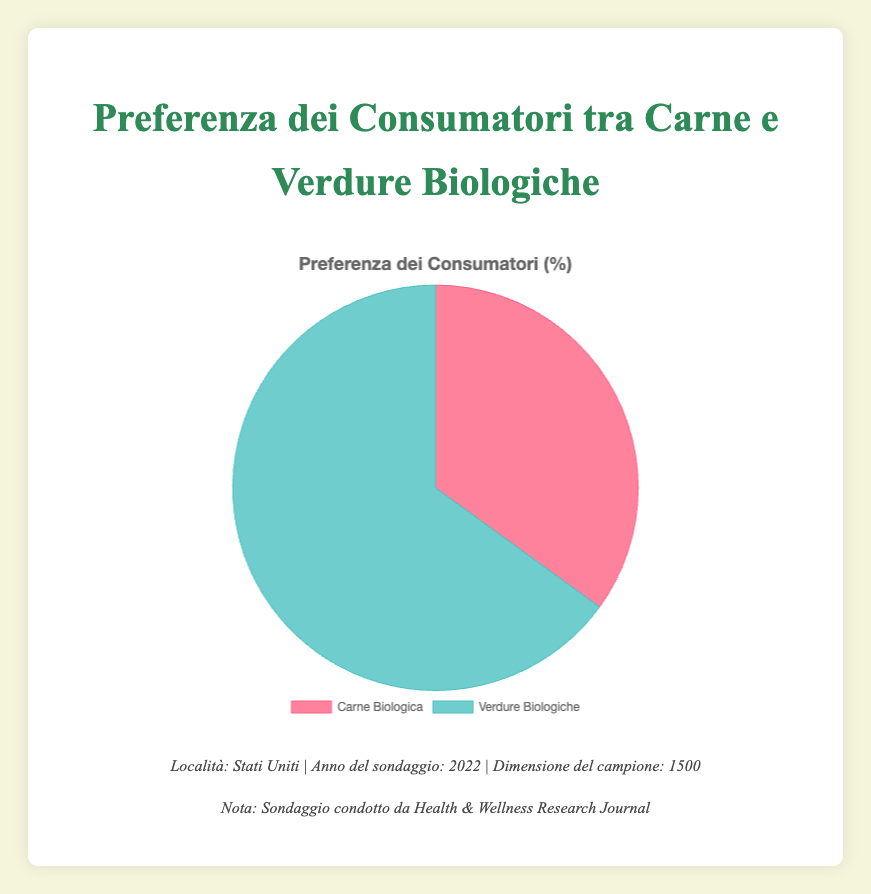What percentage of consumers prefer organic meat? The pie chart displays two segments representing consumer preferences. The segment for "Organic Meat" shows a 35% value. This indicates that 35% of consumers prefer organic meat.
Answer: 35% What is the most preferred organic product among consumers? By observing the pie chart, it is clear that the larger segment represents "Organic Vegetables" with a value of 65%. This is higher compared to 35% for "Organic Meat", making organic vegetables the most preferred product.
Answer: Organic Vegetables What is the difference in preference percentage between organic meat and organic vegetables? The pie chart shows that organic meat has a preference of 35%, and organic vegetables have 65%. Subtracting 35 from 65 gives us the difference in preference percentages.
Answer: 30% What fraction of the sample prefers organic vegetables? The pie chart indicates that 65% of consumers prefer organic vegetables. To convert this percentage into a fraction, we can write 65% as 65/100 and simplify it to 13/20.
Answer: 13/20 If you were to conduct a survey with 2000 participants, how many would you expect to prefer organic meat based on the current data? According to the pie chart, 35% of the current sample prefers organic meat. Applying this percentage to a new sample of 2000 participants: 35% of 2000 is (35/100) * 2000, which equals 700.
Answer: 700 What proportion of the surveyed consumers prefers organic meat over organic vegetables? The pie chart values are 35% for organic meat and 65% for organic vegetables. The proportion of meat to vegetables is calculated as 35/65, which simplifies to 7/13.
Answer: 7/13 Which segment is illustrated with a green color in the pie chart? Visual inspection of the pie chart reveals that the segment for "Organic Vegetables" is colored green.
Answer: Organic Vegetables What would be the total preference percentage if both categories had the same number of consumers? If both categories were to be equally preferred, each segment would account for half of the total, leading to a preference percentage of 50% for both categories.
Answer: 50% What is the ratio of consumers preferring organic vegetables to those preferring organic meat, and how is it represented visually? According to the pie chart, 65% prefer organic vegetables and 35% prefer organic meat. The ratio of vegetable preference to meat preference is 65:35, which simplifies to 13:7. Visually, this is represented by the larger green segment for vegetables and the smaller red segment for meat.
Answer: 13:7 